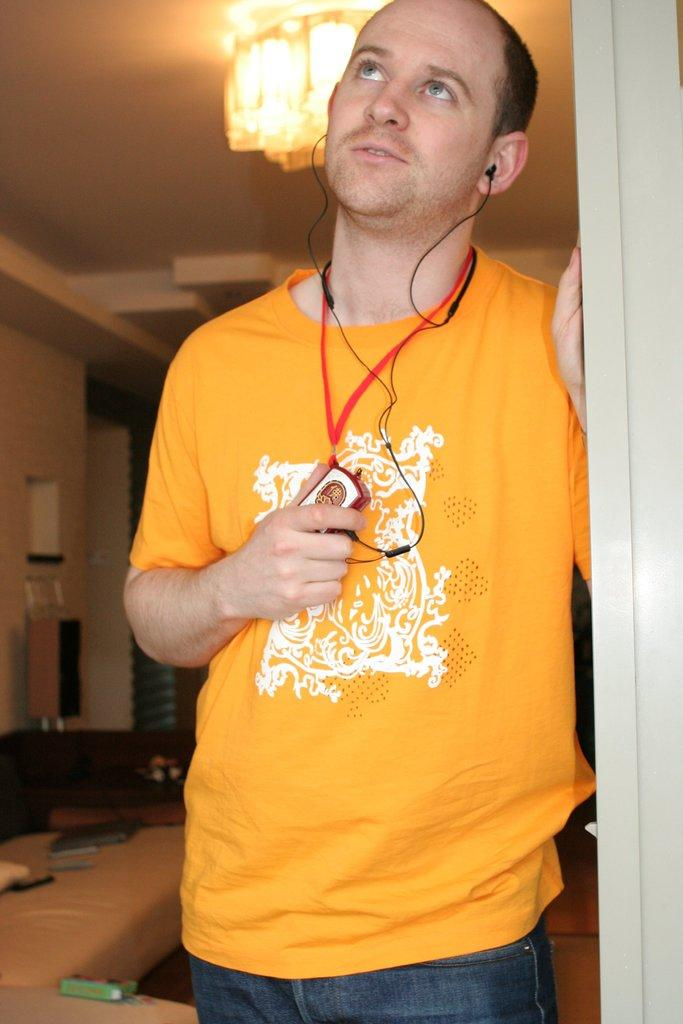What is the man in the image doing? The man is standing in the image and holding a device. What might the man be using the device for? The man could be using the device for listening to music or other audio, as earphones are visible in the image. What type of furniture is present in the image? There is a sofa in the image. What other audio equipment is present in the image? There is a speaker in the image. Can you describe any unspecified objects in the image? Unfortunately, the facts provided do not give any details about the unspecified objects. What can be seen in the background of the image? There is a wall in the background of the image. What type of alarm can be seen on the wall in the image? There is no alarm present on the wall in the image. What type of teeth can be seen in the image? There are no teeth visible in the image. Can you see an airplane in the image? No, there is no airplane present in the image. 